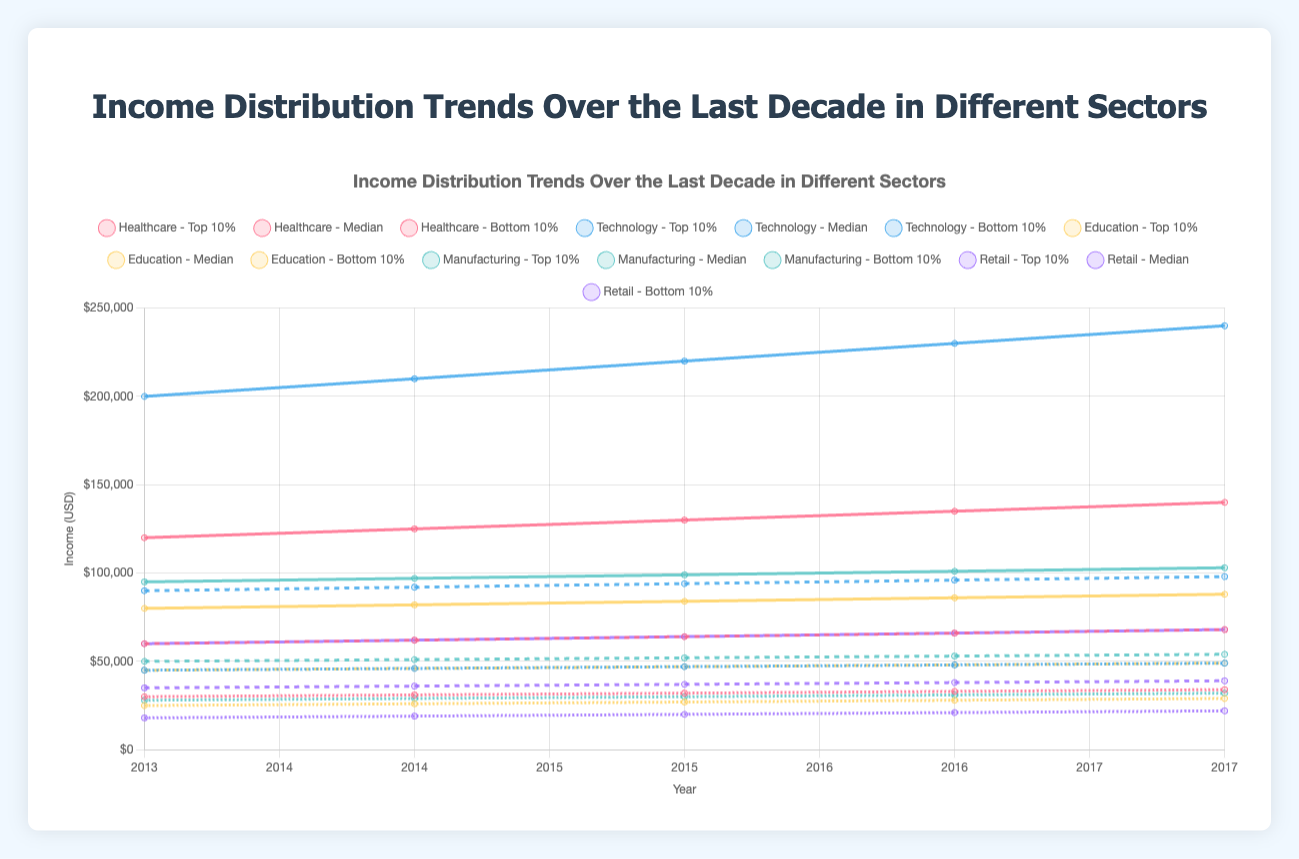Which sector had the highest median income in 2017? By observing the median income lines on the graph, the Technology sector had the highest median income in 2017.
Answer: Technology How much did the median income in Healthcare increase from 2013 to 2017? The median income in Healthcare increased from $60,000 in 2013 to $68,000 in 2017. The difference is $68,000 - $60,000 = $8,000.
Answer: $8,000 Which sector had the smallest gap between the top 10% income and the bottom 10% income in 2014? By comparing the gaps between the top 10% income and the bottom 10% income lines for different sectors in 2014, Retail had the smallest gap. It is ($62,000 - $19,000 = $43,000).
Answer: Retail In which year did the Manufacturing sector have a median income of $52,000? By locating the intersection of the median income line for Manufacturing sector and the $52,000 line, it was in the year 2015.
Answer: 2015 What was the average top 10% income for the Education sector from 2013 to 2017? To determine the average, we sum the top 10% incomes from 2013 to 2017 ($80,000 + $82,000 + $84,000 + $86,000 + $88,000 = $420,000) and divide by the number of years (5). The average is $420,000 / 5 = $84,000.
Answer: $84,000 Between Healthcare and Technology sectors, which had a higher bottom 10% income in 2016? By comparing the bottom 10% income lines for Healthcare and Technology in 2016, Technology had a higher bottom 10% income ($48,000 vs $33,000).
Answer: Technology From 2013 to 2017, by how much did the median income in the Retail sector increase? The median income in the Retail sector increased from $35,000 in 2013 to $39,000 in 2017. The difference is $39,000 - $35,000 = $4,000.
Answer: $4,000 Which sector saw the largest increase in top 10% income between 2013 and 2017? Comparing the increase in top 10% income for all sectors, Technology saw the largest increase from $200,000 in 2013 to $240,000 in 2017, an increase of $40,000.
Answer: Technology 